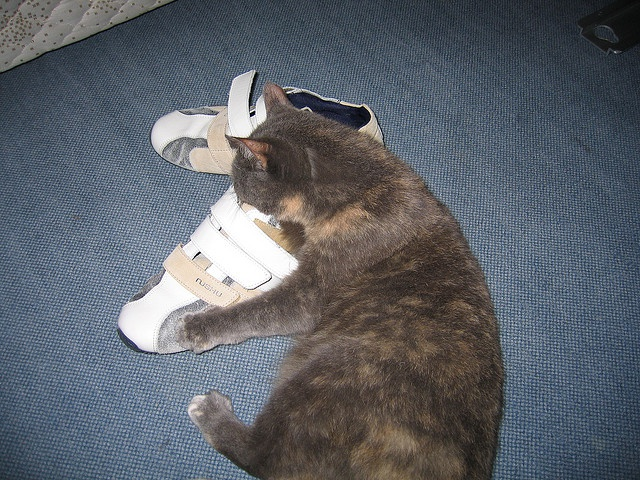Describe the objects in this image and their specific colors. I can see cat in gray and black tones and bed in gray tones in this image. 